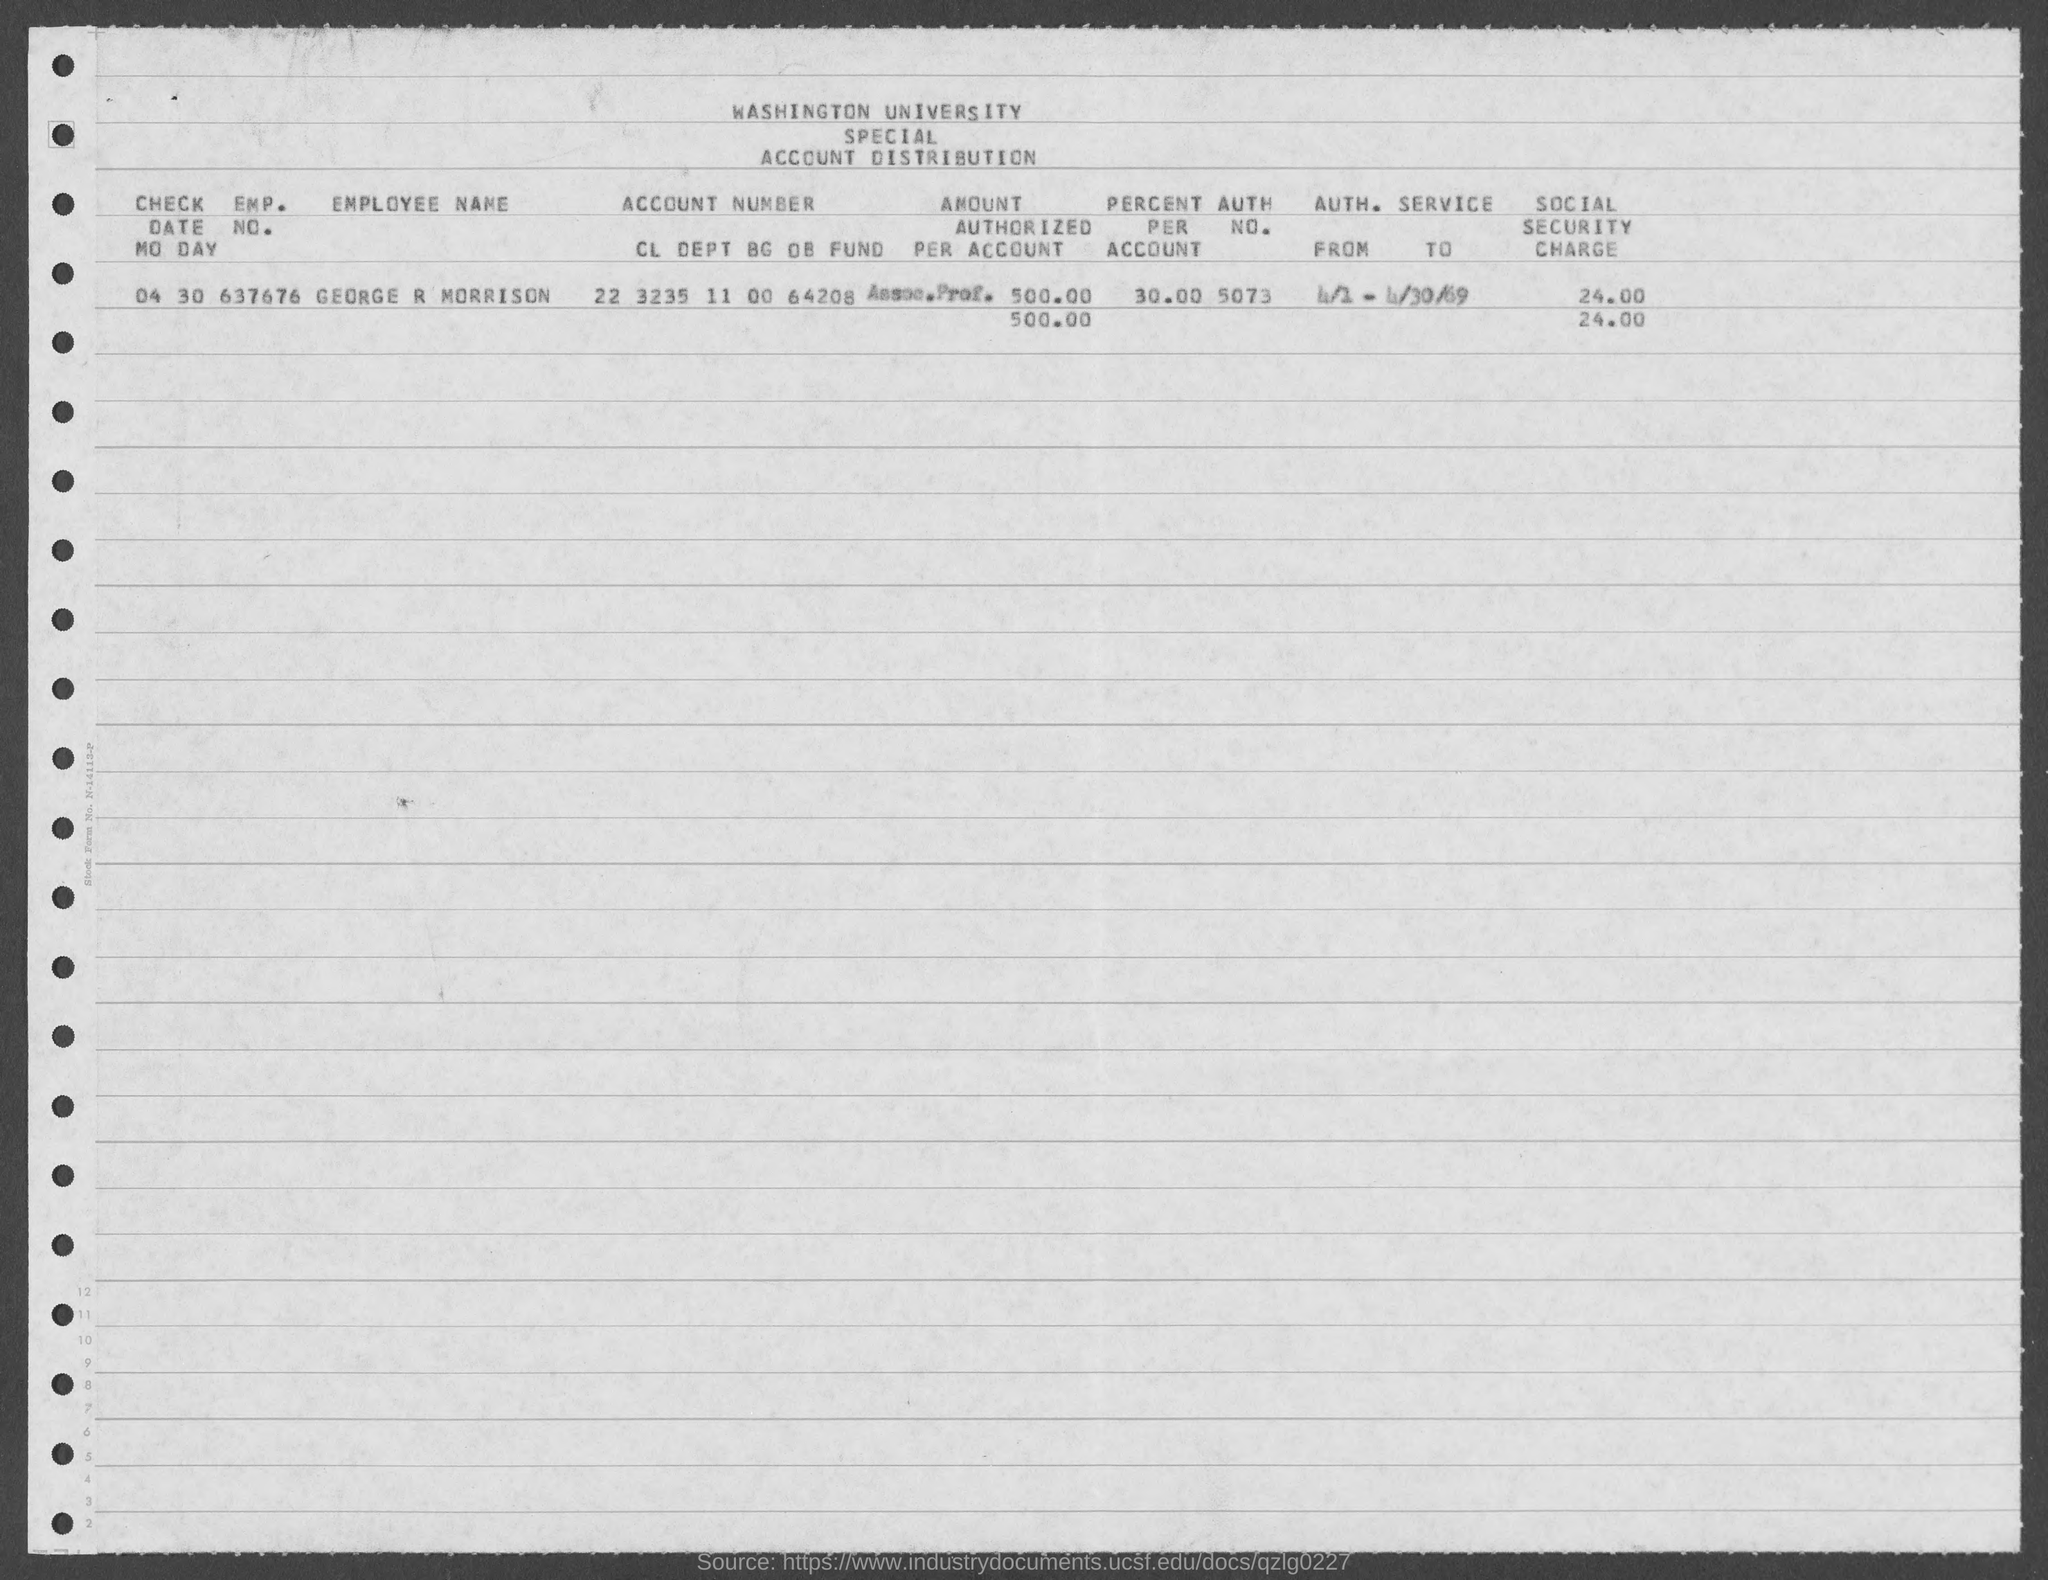Mention a couple of crucial points in this snapshot. The distribution of the account of Washington University is given here. The AUTH. NO. of the document is 5073, as appeared in the text given as 'What is the AUTH. NO. of GEORGE R MORRISON given in the document? 5073..'. The social security charge for Emp No. 637676 is 24.00. The percentage of GEORGE R MORRISON is 30.00%. The amount authorized per account of George R Morrison is $500.00. 